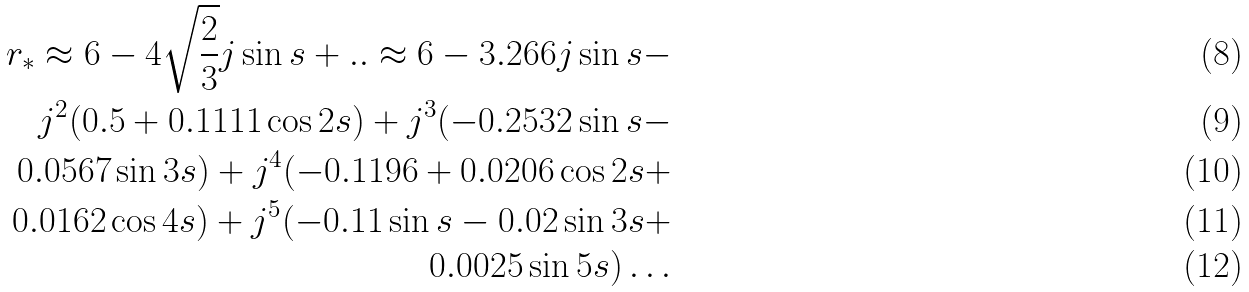<formula> <loc_0><loc_0><loc_500><loc_500>r _ { * } \approx 6 - 4 \sqrt { \frac { 2 } { 3 } } j \sin { s } + . . \approx 6 - 3 . 2 6 6 j \sin { s } - \\ j ^ { 2 } ( 0 . 5 + 0 . 1 1 1 1 \cos { 2 s } ) + j ^ { 3 } ( - 0 . 2 5 3 2 \sin { s } - \\ 0 . 0 5 6 7 \sin { 3 s } ) + j ^ { 4 } ( - 0 . 1 1 9 6 + 0 . 0 2 0 6 \cos { 2 s } + \\ 0 . 0 1 6 2 \cos { 4 s } ) + j ^ { 5 } ( - 0 . 1 1 \sin { s } - 0 . 0 2 \sin { 3 s } + \\ 0 . 0 0 2 5 \sin { 5 s } ) \dots</formula> 